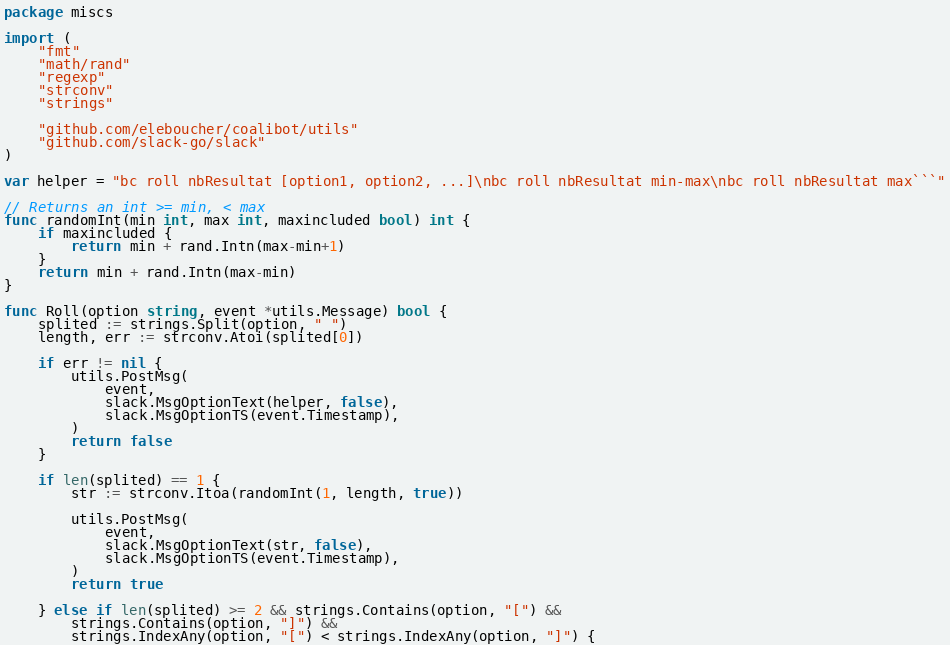Convert code to text. <code><loc_0><loc_0><loc_500><loc_500><_Go_>package miscs

import (
	"fmt"
	"math/rand"
	"regexp"
	"strconv"
	"strings"

	"github.com/eleboucher/coalibot/utils"
	"github.com/slack-go/slack"
)

var helper = "bc roll nbResultat [option1, option2, ...]\nbc roll nbResultat min-max\nbc roll nbResultat max```"

// Returns an int >= min, < max
func randomInt(min int, max int, maxincluded bool) int {
	if maxincluded {
		return min + rand.Intn(max-min+1)
	}
	return min + rand.Intn(max-min)
}

func Roll(option string, event *utils.Message) bool {
	splited := strings.Split(option, " ")
	length, err := strconv.Atoi(splited[0])

	if err != nil {
		utils.PostMsg(
			event,
			slack.MsgOptionText(helper, false),
			slack.MsgOptionTS(event.Timestamp),
		)
		return false
	}

	if len(splited) == 1 {
		str := strconv.Itoa(randomInt(1, length, true))

		utils.PostMsg(
			event,
			slack.MsgOptionText(str, false),
			slack.MsgOptionTS(event.Timestamp),
		)
		return true

	} else if len(splited) >= 2 && strings.Contains(option, "[") &&
		strings.Contains(option, "]") &&
		strings.IndexAny(option, "[") < strings.IndexAny(option, "]") {</code> 